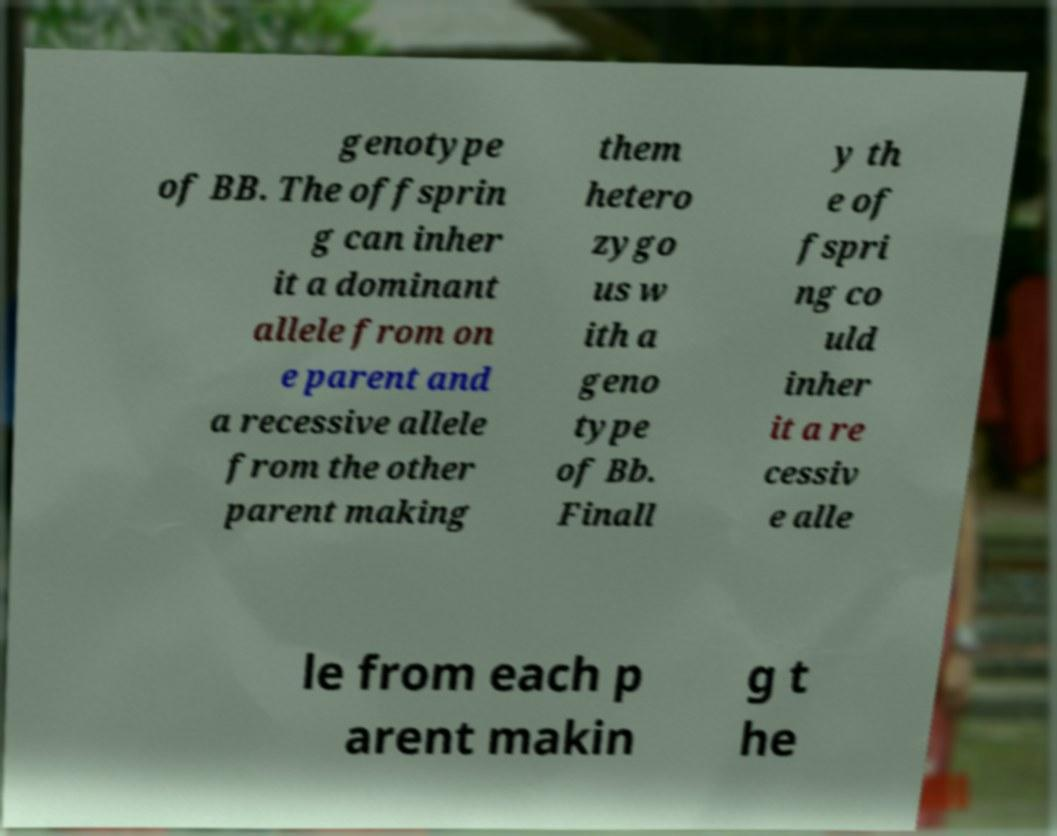Please identify and transcribe the text found in this image. genotype of BB. The offsprin g can inher it a dominant allele from on e parent and a recessive allele from the other parent making them hetero zygo us w ith a geno type of Bb. Finall y th e of fspri ng co uld inher it a re cessiv e alle le from each p arent makin g t he 